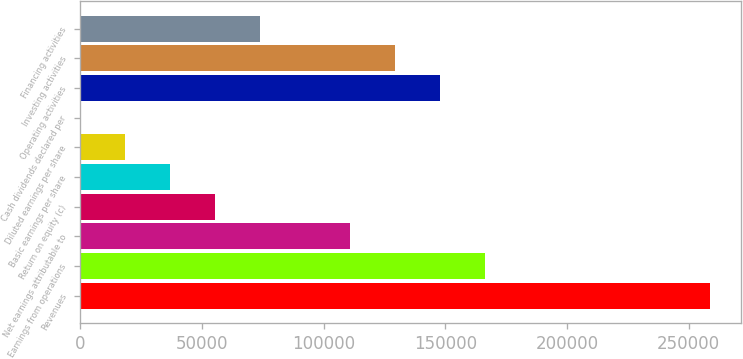Convert chart. <chart><loc_0><loc_0><loc_500><loc_500><bar_chart><fcel>Revenues<fcel>Earnings from operations<fcel>Net earnings attributable to<fcel>Return on equity (c)<fcel>Basic earnings per share<fcel>Diluted earnings per share<fcel>Cash dividends declared per<fcel>Operating activities<fcel>Investing activities<fcel>Financing activities<nl><fcel>258775<fcel>166356<fcel>110905<fcel>55453.7<fcel>36969.9<fcel>18486.1<fcel>2.38<fcel>147872<fcel>129389<fcel>73937.4<nl></chart> 